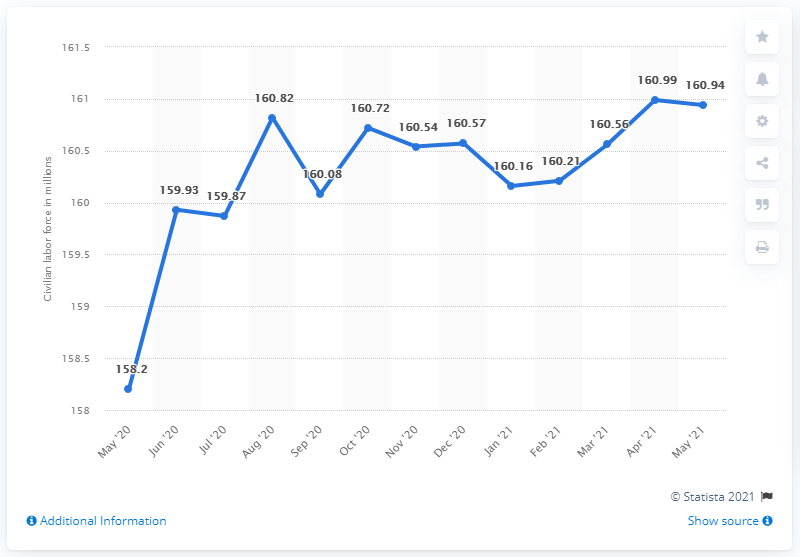Indicate a few pertinent items in this graphic. In May 2021, there were 160.94 people in the U.S. civilian labor force. 